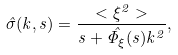<formula> <loc_0><loc_0><loc_500><loc_500>\hat { \sigma } ( k , s ) = \frac { < \xi ^ { 2 } > } { s + \hat { \Phi _ { \xi } } ( s ) k ^ { 2 } } ,</formula> 